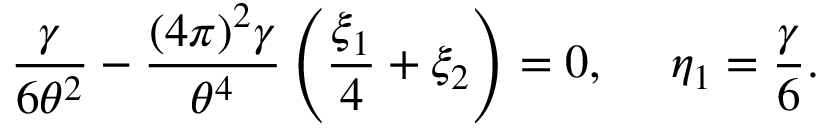Convert formula to latex. <formula><loc_0><loc_0><loc_500><loc_500>\frac { \gamma } { 6 \theta ^ { 2 } } - \frac { ( 4 \pi ) ^ { 2 } \gamma } { \theta ^ { 4 } } \left ( \frac { \xi _ { 1 } } { 4 } + \xi _ { 2 } \right ) = 0 , \quad \eta _ { 1 } = \frac { \gamma } { 6 } .</formula> 